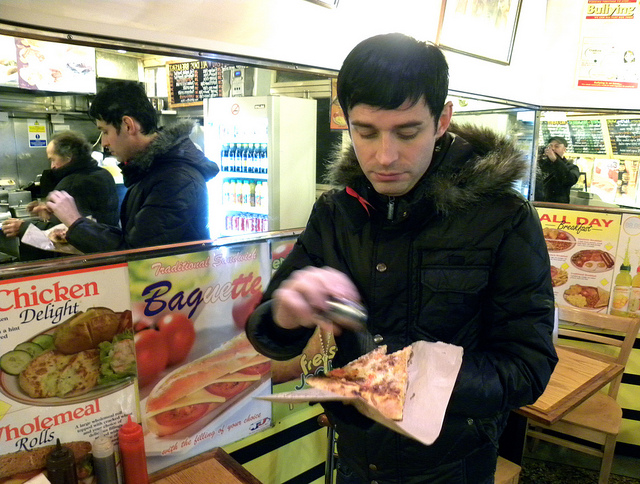What toppings can you identify on the pizza? The image shows a slice of pizza with what seems to be cheese and possibly pepperoni, but it is not clearly visible to provide a definitive answer. How does the man seem to feel about his pizza? The man appears to be concentrating on adding something to his pizza, perhaps suggesting he is intent on improving its taste to his liking. 